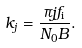<formula> <loc_0><loc_0><loc_500><loc_500>k _ { j } = \frac { \pi j f _ { \text {i} } } { N _ { 0 } B } .</formula> 